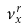Convert formula to latex. <formula><loc_0><loc_0><loc_500><loc_500>\nu _ { x } ^ { r }</formula> 